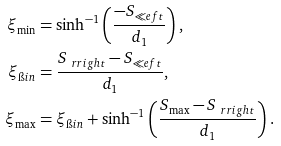<formula> <loc_0><loc_0><loc_500><loc_500>\xi _ { \min } & = \sinh ^ { - 1 } \left ( \frac { - S _ { \ll e f t } } { d _ { 1 } } \right ) , \\ \xi _ { \i i n } & = \frac { S _ { \ r r i g h t } - S _ { \ll e f t } } { d _ { 1 } } , \\ \xi _ { \max } & = \xi _ { \i i n } + \sinh ^ { - 1 } \left ( \frac { S _ { \max } - S _ { \ r r i g h t } } { d _ { 1 } } \right ) .</formula> 